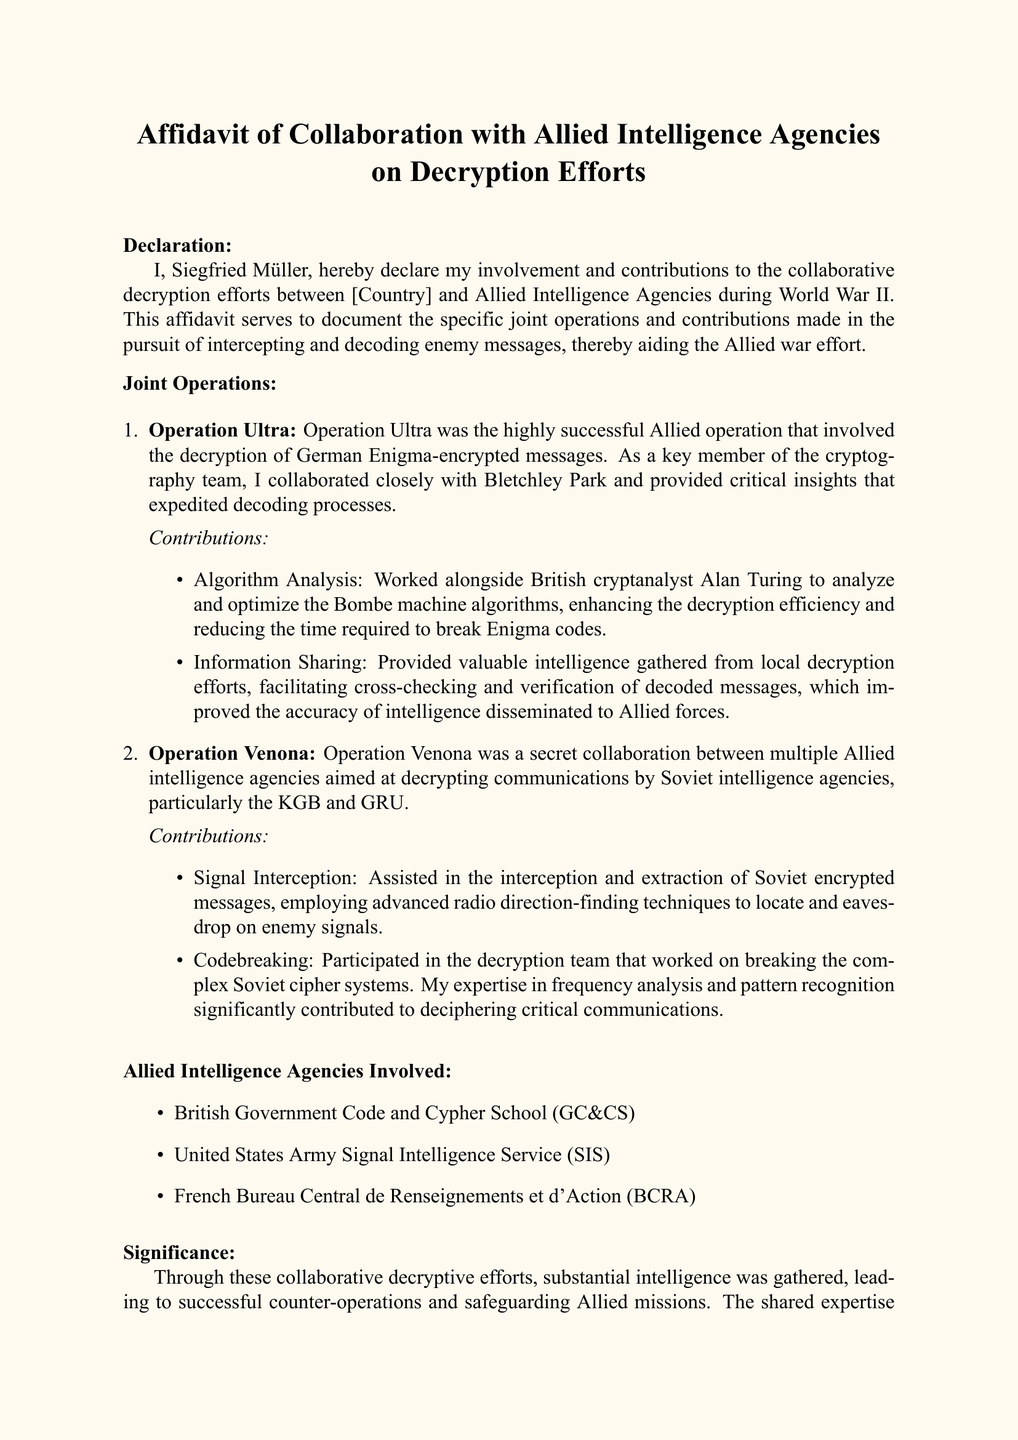What is the name of the declarant? The declarant's name is stated at the beginning of the affidavit as Siegfried Müller.
Answer: Siegfried Müller What operation involved the decryption of German Enigma-encrypted messages? The document describes Operation Ultra as the operation that decrypted German Enigma-encrypted messages.
Answer: Operation Ultra Which Allied Intelligence Agency is mentioned first in the list? The first agency mentioned in the list of Allied Intelligence Agencies is the British Government Code and Cypher School (GC&CS).
Answer: British Government Code and Cypher School (GC&CS) What technique was used to intercept Soviet encrypted messages? The affidavit mentions "advanced radio direction-finding techniques" as the method used to intercept Soviet messages.
Answer: advanced radio direction-finding techniques What was Siegfried Müller's role in Operation Ultra? His role included collaborating closely with Bletchley Park and providing critical insights for the decryption efforts.
Answer: collaborating closely with Bletchley Park What was a significant contribution of Siegfried Müller in Operation Venona? The document states he participated in the decryption team that worked on breaking complex Soviet cipher systems.
Answer: breaking complex Soviet cipher systems How many joint operations are described in the affidavit? The affidavit describes two joint operations: Operation Ultra and Operation Venona.
Answer: two What does the affidavit affirm about the document's content? It affirms that the testimonies and descriptions provided are accurate and truthful to the best of the declarant's knowledge.
Answer: accurate and truthful 